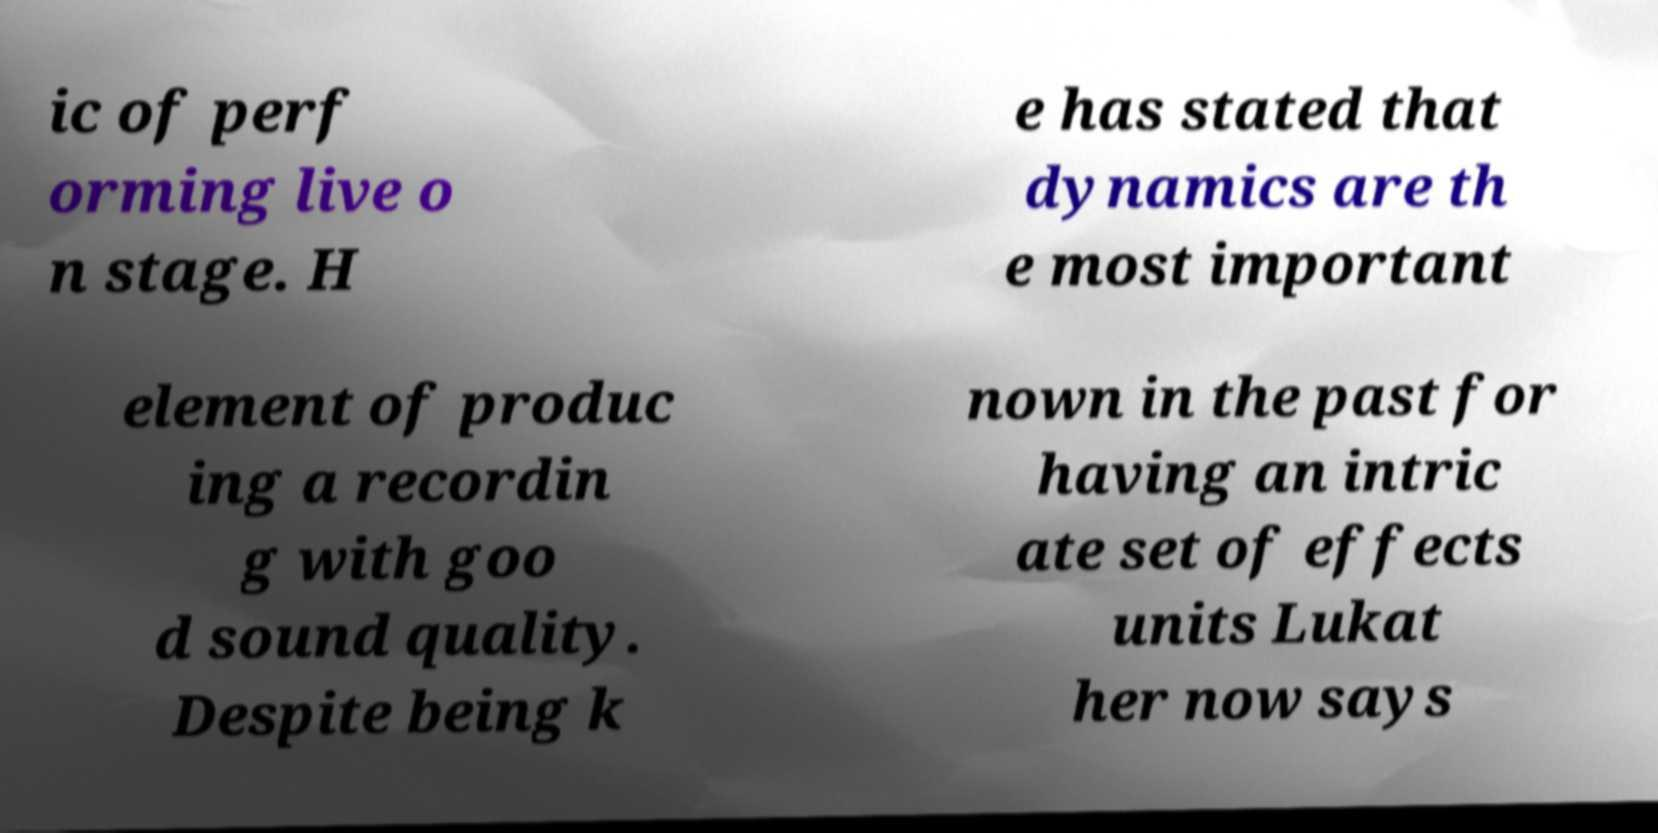Could you extract and type out the text from this image? ic of perf orming live o n stage. H e has stated that dynamics are th e most important element of produc ing a recordin g with goo d sound quality. Despite being k nown in the past for having an intric ate set of effects units Lukat her now says 